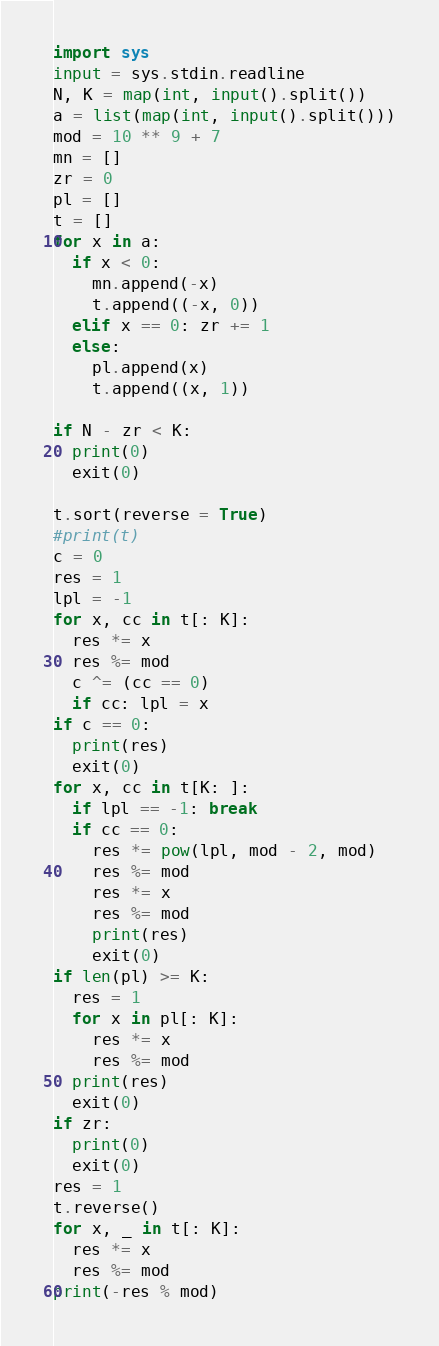Convert code to text. <code><loc_0><loc_0><loc_500><loc_500><_Python_>import sys
input = sys.stdin.readline
N, K = map(int, input().split())
a = list(map(int, input().split()))
mod = 10 ** 9 + 7
mn = []
zr = 0
pl = []
t = []
for x in a:
  if x < 0:
    mn.append(-x)
    t.append((-x, 0))
  elif x == 0: zr += 1
  else:
    pl.append(x)
    t.append((x, 1))

if N - zr < K:
  print(0)
  exit(0)

t.sort(reverse = True)
#print(t)
c = 0
res = 1
lpl = -1
for x, cc in t[: K]:
  res *= x
  res %= mod
  c ^= (cc == 0)
  if cc: lpl = x
if c == 0:
  print(res)
  exit(0)
for x, cc in t[K: ]:
  if lpl == -1: break
  if cc == 0:
    res *= pow(lpl, mod - 2, mod)
    res %= mod
    res *= x
    res %= mod
    print(res)
    exit(0)
if len(pl) >= K:
  res = 1
  for x in pl[: K]:
    res *= x
    res %= mod
  print(res)
  exit(0)
if zr:
  print(0)
  exit(0)
res = 1
t.reverse()
for x, _ in t[: K]:
  res *= x
  res %= mod
print(-res % mod)</code> 